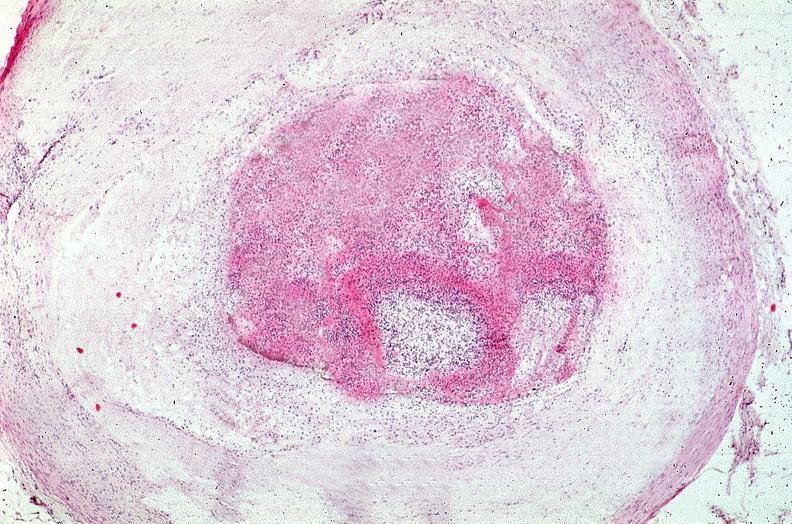what is present?
Answer the question using a single word or phrase. Cardiovascular 